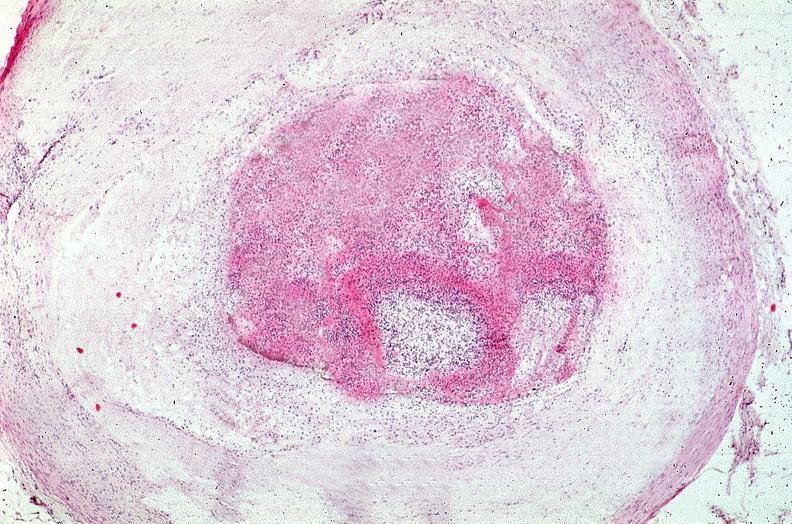what is present?
Answer the question using a single word or phrase. Cardiovascular 